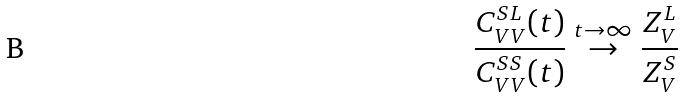Convert formula to latex. <formula><loc_0><loc_0><loc_500><loc_500>\frac { C ^ { S L } _ { V V } ( t ) } { C ^ { S S } _ { V V } ( t ) } \stackrel { t \to \infty } \to \frac { Z _ { V } ^ { L } } { Z _ { V } ^ { S } }</formula> 